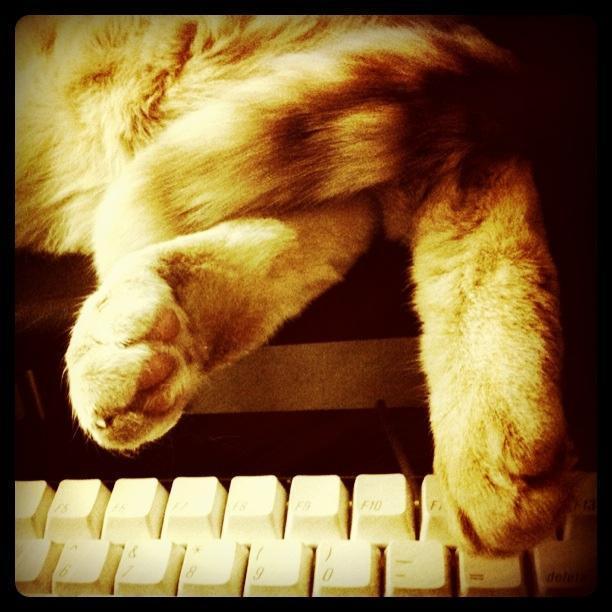How many clock faces are visible?
Give a very brief answer. 0. 